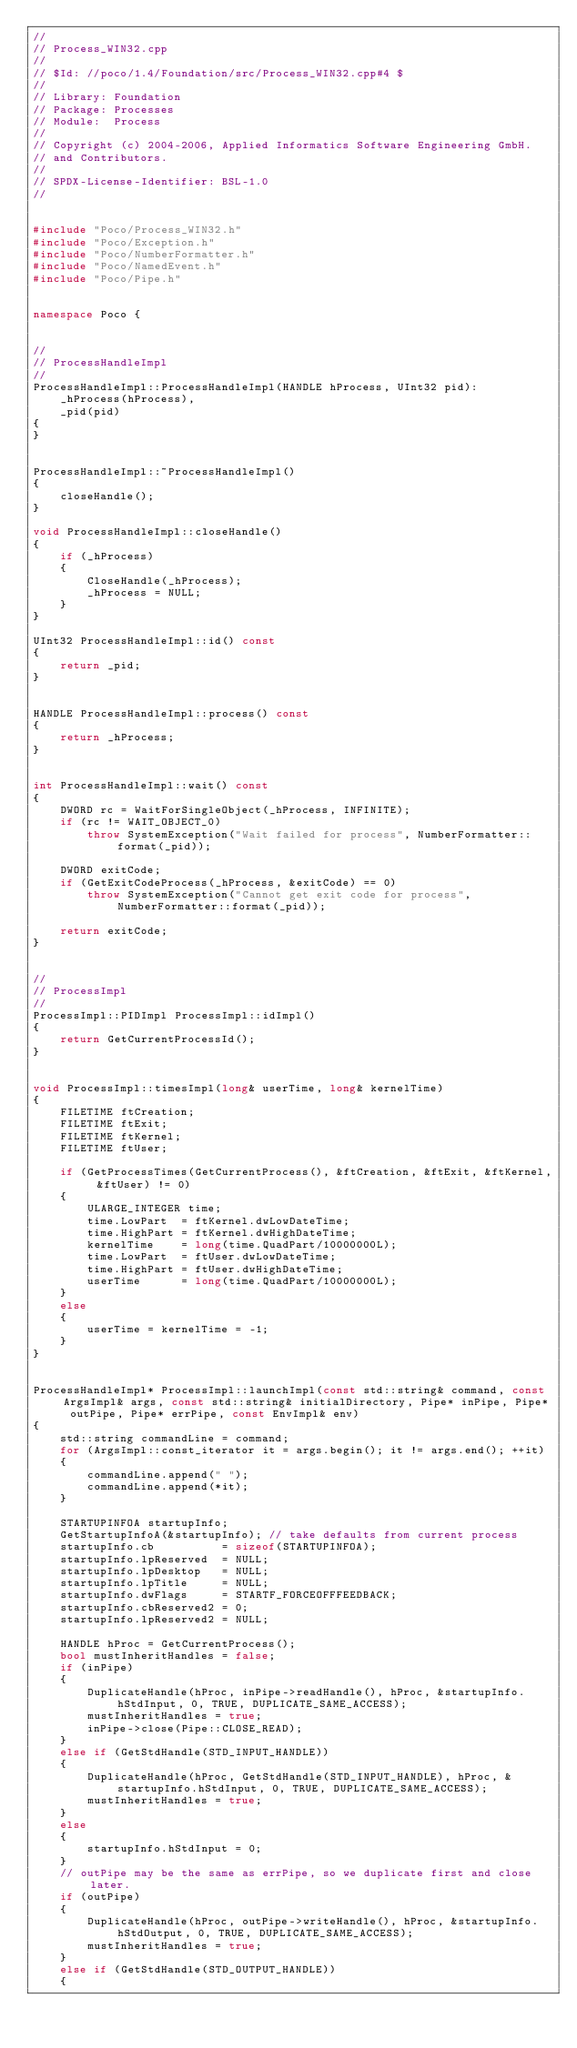<code> <loc_0><loc_0><loc_500><loc_500><_C++_>//
// Process_WIN32.cpp
//
// $Id: //poco/1.4/Foundation/src/Process_WIN32.cpp#4 $
//
// Library: Foundation
// Package: Processes
// Module:  Process
//
// Copyright (c) 2004-2006, Applied Informatics Software Engineering GmbH.
// and Contributors.
//
// SPDX-License-Identifier:	BSL-1.0
//


#include "Poco/Process_WIN32.h"
#include "Poco/Exception.h"
#include "Poco/NumberFormatter.h"
#include "Poco/NamedEvent.h"
#include "Poco/Pipe.h"


namespace Poco {


//
// ProcessHandleImpl
//
ProcessHandleImpl::ProcessHandleImpl(HANDLE hProcess, UInt32 pid):
	_hProcess(hProcess),
	_pid(pid)
{
}


ProcessHandleImpl::~ProcessHandleImpl()
{
	closeHandle();
}

void ProcessHandleImpl::closeHandle()
{
	if (_hProcess)
	{
		CloseHandle(_hProcess);
		_hProcess = NULL;
	}
}

UInt32 ProcessHandleImpl::id() const
{
	return _pid;
}


HANDLE ProcessHandleImpl::process() const
{
	return _hProcess;
}


int ProcessHandleImpl::wait() const
{
	DWORD rc = WaitForSingleObject(_hProcess, INFINITE);
	if (rc != WAIT_OBJECT_0)
		throw SystemException("Wait failed for process", NumberFormatter::format(_pid));

	DWORD exitCode;
	if (GetExitCodeProcess(_hProcess, &exitCode) == 0)
		throw SystemException("Cannot get exit code for process", NumberFormatter::format(_pid));

	return exitCode;
}


//
// ProcessImpl
//
ProcessImpl::PIDImpl ProcessImpl::idImpl()
{
	return GetCurrentProcessId(); 
}


void ProcessImpl::timesImpl(long& userTime, long& kernelTime)
{
	FILETIME ftCreation;
	FILETIME ftExit;
	FILETIME ftKernel;
	FILETIME ftUser;

	if (GetProcessTimes(GetCurrentProcess(), &ftCreation, &ftExit, &ftKernel, &ftUser) != 0)
	{
		ULARGE_INTEGER time;
		time.LowPart  = ftKernel.dwLowDateTime;
		time.HighPart = ftKernel.dwHighDateTime;
		kernelTime    = long(time.QuadPart/10000000L);
		time.LowPart  = ftUser.dwLowDateTime;
		time.HighPart = ftUser.dwHighDateTime;
		userTime      = long(time.QuadPart/10000000L);
	}
	else
	{
		userTime = kernelTime = -1;
	}
}


ProcessHandleImpl* ProcessImpl::launchImpl(const std::string& command, const ArgsImpl& args, const std::string& initialDirectory, Pipe* inPipe, Pipe* outPipe, Pipe* errPipe, const EnvImpl& env)
{
	std::string commandLine = command;
	for (ArgsImpl::const_iterator it = args.begin(); it != args.end(); ++it)
	{
		commandLine.append(" ");
		commandLine.append(*it);
	}		

	STARTUPINFOA startupInfo;
	GetStartupInfoA(&startupInfo); // take defaults from current process
	startupInfo.cb          = sizeof(STARTUPINFOA);
	startupInfo.lpReserved  = NULL;
	startupInfo.lpDesktop   = NULL;
	startupInfo.lpTitle     = NULL;
	startupInfo.dwFlags     = STARTF_FORCEOFFFEEDBACK;
	startupInfo.cbReserved2 = 0;
	startupInfo.lpReserved2 = NULL;

	HANDLE hProc = GetCurrentProcess();
	bool mustInheritHandles = false;
	if (inPipe)
	{
		DuplicateHandle(hProc, inPipe->readHandle(), hProc, &startupInfo.hStdInput, 0, TRUE, DUPLICATE_SAME_ACCESS);
		mustInheritHandles = true;
		inPipe->close(Pipe::CLOSE_READ);
	}
	else if (GetStdHandle(STD_INPUT_HANDLE))
	{
		DuplicateHandle(hProc, GetStdHandle(STD_INPUT_HANDLE), hProc, &startupInfo.hStdInput, 0, TRUE, DUPLICATE_SAME_ACCESS);
		mustInheritHandles = true;
	}
	else 
	{
		startupInfo.hStdInput = 0;
	}
	// outPipe may be the same as errPipe, so we duplicate first and close later.
	if (outPipe)
	{
		DuplicateHandle(hProc, outPipe->writeHandle(), hProc, &startupInfo.hStdOutput, 0, TRUE, DUPLICATE_SAME_ACCESS);
		mustInheritHandles = true;
	}
	else if (GetStdHandle(STD_OUTPUT_HANDLE))
	{</code> 